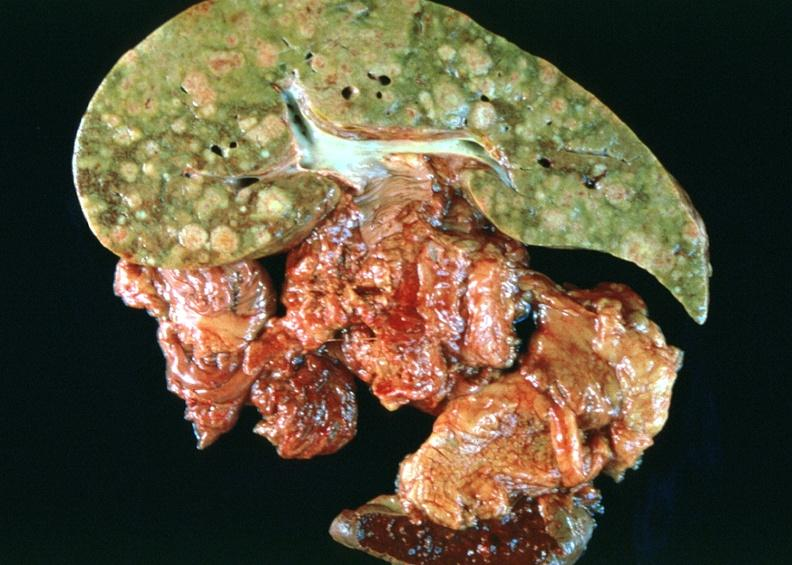does this image show breast cancer metastasis to liver?
Answer the question using a single word or phrase. Yes 